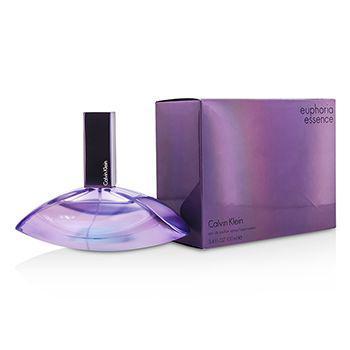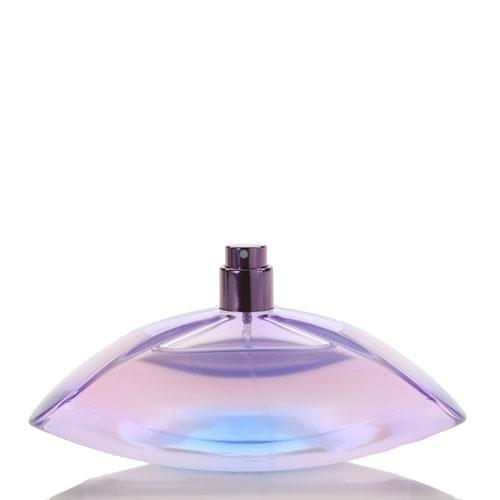The first image is the image on the left, the second image is the image on the right. Given the left and right images, does the statement "There is a box beside the bottle in one of the images." hold true? Answer yes or no. Yes. 